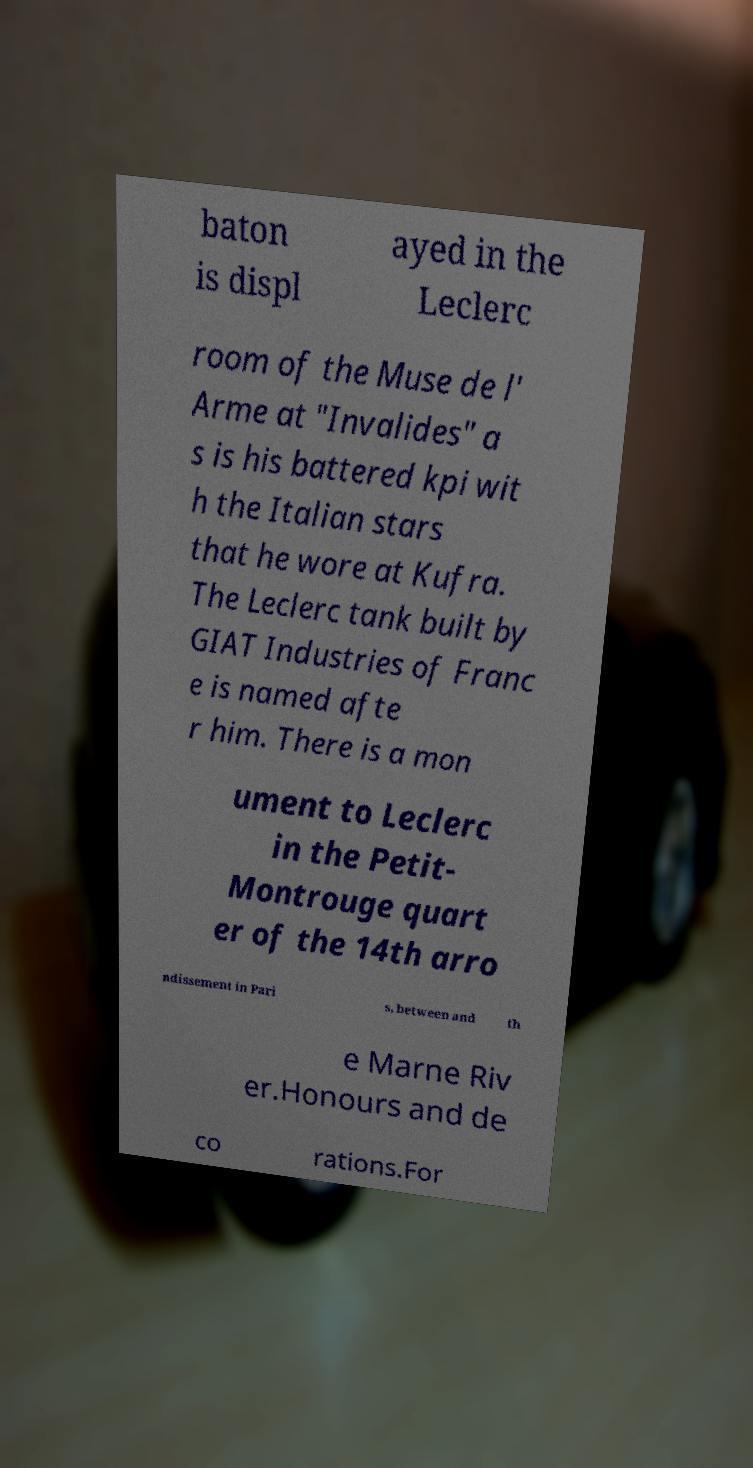For documentation purposes, I need the text within this image transcribed. Could you provide that? baton is displ ayed in the Leclerc room of the Muse de l' Arme at "Invalides" a s is his battered kpi wit h the Italian stars that he wore at Kufra. The Leclerc tank built by GIAT Industries of Franc e is named afte r him. There is a mon ument to Leclerc in the Petit- Montrouge quart er of the 14th arro ndissement in Pari s, between and th e Marne Riv er.Honours and de co rations.For 